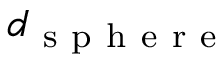Convert formula to latex. <formula><loc_0><loc_0><loc_500><loc_500>d _ { s p h e r e }</formula> 